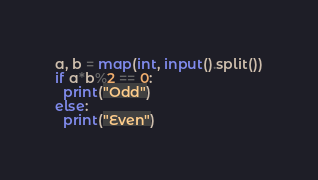Convert code to text. <code><loc_0><loc_0><loc_500><loc_500><_Python_>a, b = map(int, input().split())
if a*b%2 == 0:
  print("Odd")
else:
  print("Even")</code> 